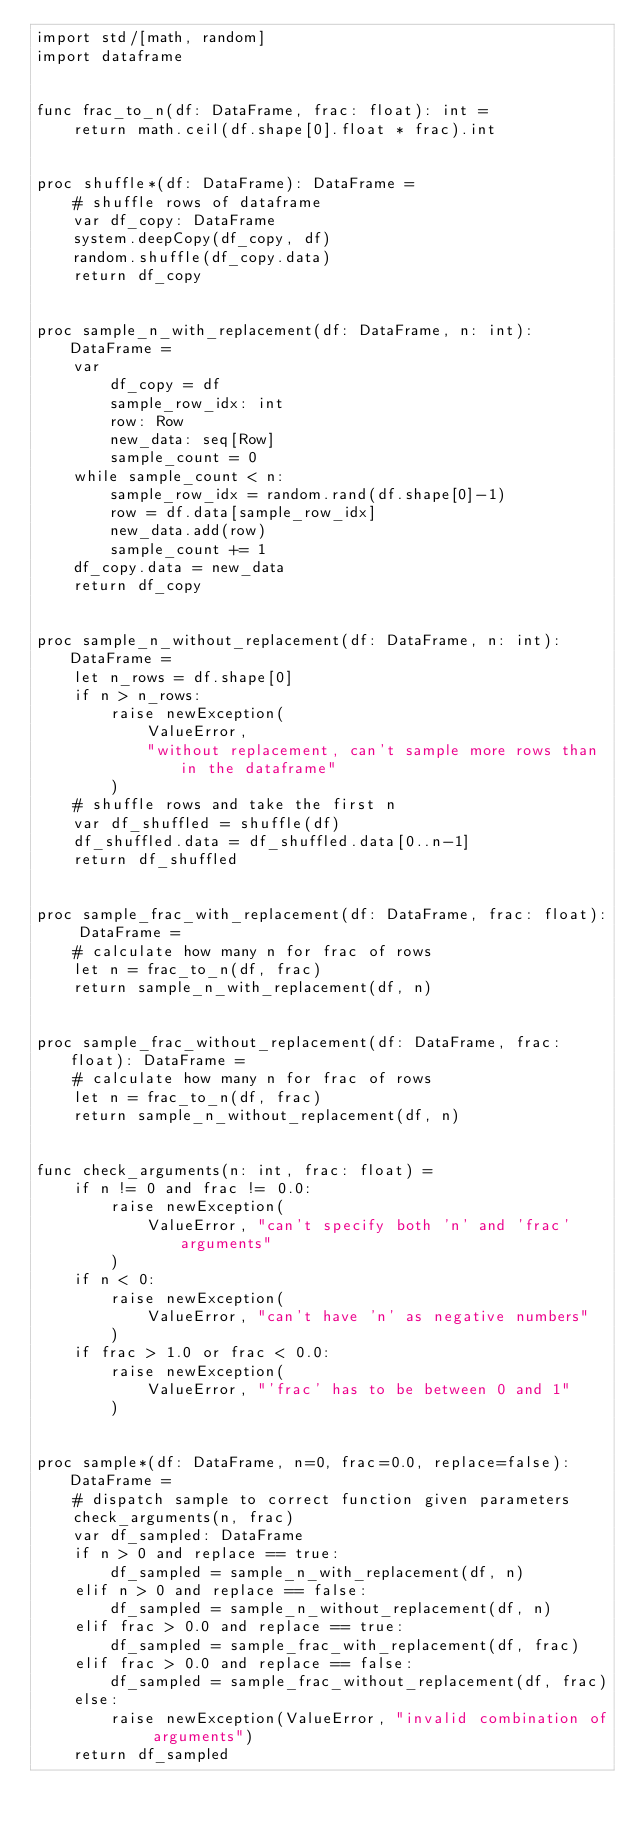<code> <loc_0><loc_0><loc_500><loc_500><_Nim_>import std/[math, random]
import dataframe


func frac_to_n(df: DataFrame, frac: float): int =
    return math.ceil(df.shape[0].float * frac).int


proc shuffle*(df: DataFrame): DataFrame =
    # shuffle rows of dataframe
    var df_copy: DataFrame
    system.deepCopy(df_copy, df)
    random.shuffle(df_copy.data)
    return df_copy


proc sample_n_with_replacement(df: DataFrame, n: int): DataFrame =
    var
        df_copy = df
        sample_row_idx: int
        row: Row
        new_data: seq[Row]
        sample_count = 0
    while sample_count < n:
        sample_row_idx = random.rand(df.shape[0]-1)
        row = df.data[sample_row_idx]
        new_data.add(row)
        sample_count += 1
    df_copy.data = new_data
    return df_copy


proc sample_n_without_replacement(df: DataFrame, n: int): DataFrame =
    let n_rows = df.shape[0]
    if n > n_rows:
        raise newException(
            ValueError,
            "without replacement, can't sample more rows than in the dataframe"
        )
    # shuffle rows and take the first n
    var df_shuffled = shuffle(df)
    df_shuffled.data = df_shuffled.data[0..n-1]
    return df_shuffled


proc sample_frac_with_replacement(df: DataFrame, frac: float): DataFrame =
    # calculate how many n for frac of rows
    let n = frac_to_n(df, frac)
    return sample_n_with_replacement(df, n)


proc sample_frac_without_replacement(df: DataFrame, frac: float): DataFrame =
    # calculate how many n for frac of rows
    let n = frac_to_n(df, frac)
    return sample_n_without_replacement(df, n)


func check_arguments(n: int, frac: float) =
    if n != 0 and frac != 0.0:
        raise newException(
            ValueError, "can't specify both 'n' and 'frac' arguments"
        )
    if n < 0:
        raise newException(
            ValueError, "can't have 'n' as negative numbers"
        )
    if frac > 1.0 or frac < 0.0:
        raise newException(
            ValueError, "'frac' has to be between 0 and 1"
        )


proc sample*(df: DataFrame, n=0, frac=0.0, replace=false): DataFrame =
    # dispatch sample to correct function given parameters
    check_arguments(n, frac)
    var df_sampled: DataFrame
    if n > 0 and replace == true:
        df_sampled = sample_n_with_replacement(df, n)
    elif n > 0 and replace == false:
        df_sampled = sample_n_without_replacement(df, n)
    elif frac > 0.0 and replace == true:
        df_sampled = sample_frac_with_replacement(df, frac)
    elif frac > 0.0 and replace == false:
        df_sampled = sample_frac_without_replacement(df, frac)
    else:
        raise newException(ValueError, "invalid combination of arguments")
    return df_sampled
</code> 